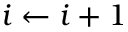Convert formula to latex. <formula><loc_0><loc_0><loc_500><loc_500>i \gets i + 1</formula> 